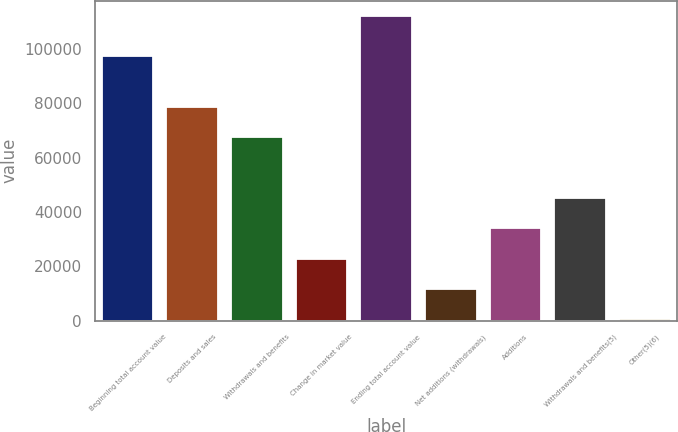Convert chart to OTSL. <chart><loc_0><loc_0><loc_500><loc_500><bar_chart><fcel>Beginning total account value<fcel>Deposits and sales<fcel>Withdrawals and benefits<fcel>Change in market value<fcel>Ending total account value<fcel>Net additions (withdrawals)<fcel>Additions<fcel>Withdrawals and benefits(5)<fcel>Other(5)(6)<nl><fcel>97430<fcel>78699.4<fcel>67535.2<fcel>22878.4<fcel>112192<fcel>11714.2<fcel>34042.6<fcel>45206.8<fcel>550<nl></chart> 